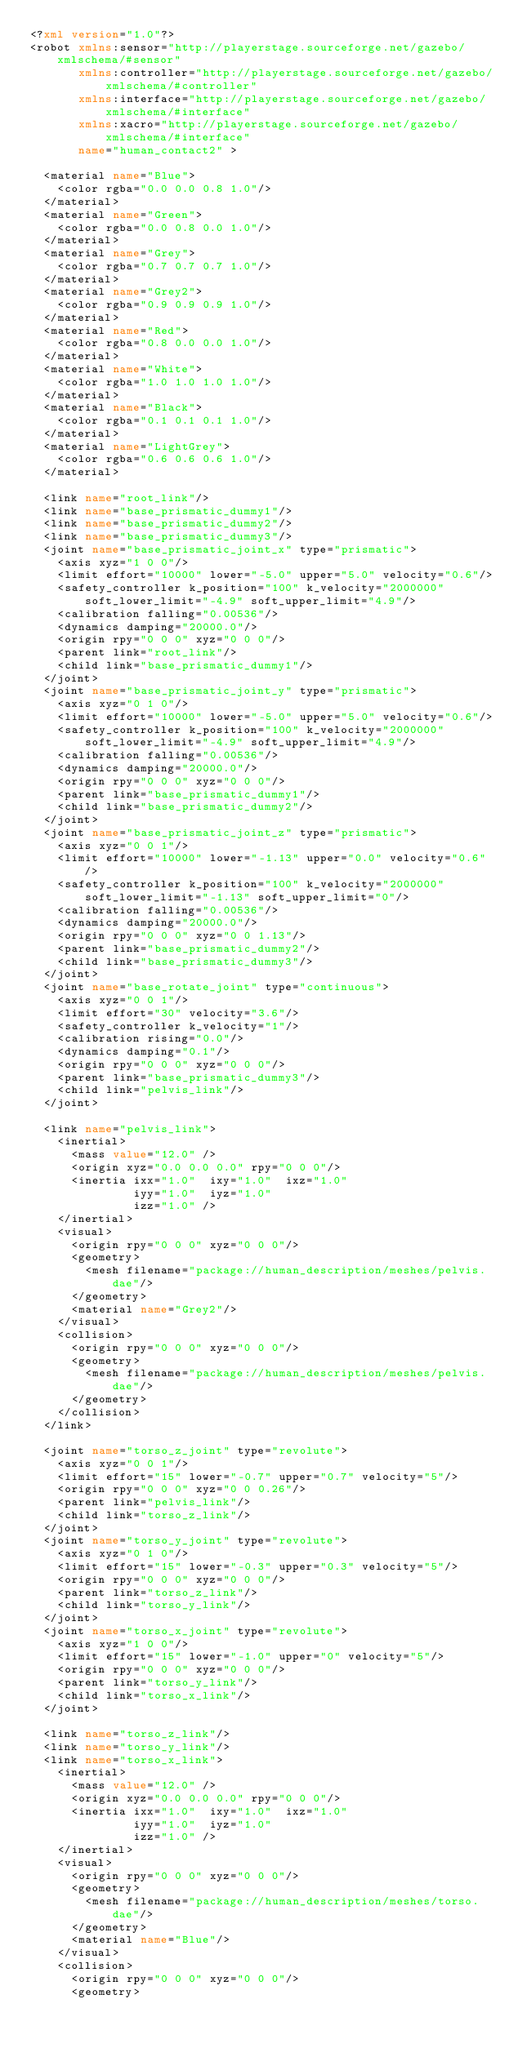<code> <loc_0><loc_0><loc_500><loc_500><_XML_><?xml version="1.0"?>
<robot xmlns:sensor="http://playerstage.sourceforge.net/gazebo/xmlschema/#sensor"
       xmlns:controller="http://playerstage.sourceforge.net/gazebo/xmlschema/#controller"
       xmlns:interface="http://playerstage.sourceforge.net/gazebo/xmlschema/#interface"
       xmlns:xacro="http://playerstage.sourceforge.net/gazebo/xmlschema/#interface"
       name="human_contact2" >

  <material name="Blue">
    <color rgba="0.0 0.0 0.8 1.0"/>
  </material>
  <material name="Green">
    <color rgba="0.0 0.8 0.0 1.0"/>
  </material>
  <material name="Grey">
    <color rgba="0.7 0.7 0.7 1.0"/>
  </material>
  <material name="Grey2">
    <color rgba="0.9 0.9 0.9 1.0"/>
  </material>
  <material name="Red">
    <color rgba="0.8 0.0 0.0 1.0"/>
  </material>
  <material name="White">
    <color rgba="1.0 1.0 1.0 1.0"/>
  </material>
  <material name="Black">
    <color rgba="0.1 0.1 0.1 1.0"/>
  </material>
  <material name="LightGrey">
    <color rgba="0.6 0.6 0.6 1.0"/>
  </material>

  <link name="root_link"/>
  <link name="base_prismatic_dummy1"/>
  <link name="base_prismatic_dummy2"/>
  <link name="base_prismatic_dummy3"/>
  <joint name="base_prismatic_joint_x" type="prismatic">
    <axis xyz="1 0 0"/>
    <limit effort="10000" lower="-5.0" upper="5.0" velocity="0.6"/>
    <safety_controller k_position="100" k_velocity="2000000" soft_lower_limit="-4.9" soft_upper_limit="4.9"/>
    <calibration falling="0.00536"/>
    <dynamics damping="20000.0"/>
    <origin rpy="0 0 0" xyz="0 0 0"/>
    <parent link="root_link"/>
    <child link="base_prismatic_dummy1"/>
  </joint>
  <joint name="base_prismatic_joint_y" type="prismatic">
    <axis xyz="0 1 0"/>
    <limit effort="10000" lower="-5.0" upper="5.0" velocity="0.6"/>
    <safety_controller k_position="100" k_velocity="2000000" soft_lower_limit="-4.9" soft_upper_limit="4.9"/>
    <calibration falling="0.00536"/>
    <dynamics damping="20000.0"/>
    <origin rpy="0 0 0" xyz="0 0 0"/>
    <parent link="base_prismatic_dummy1"/>
    <child link="base_prismatic_dummy2"/>
  </joint>
  <joint name="base_prismatic_joint_z" type="prismatic">
    <axis xyz="0 0 1"/>
    <limit effort="10000" lower="-1.13" upper="0.0" velocity="0.6"/>
    <safety_controller k_position="100" k_velocity="2000000" soft_lower_limit="-1.13" soft_upper_limit="0"/>
    <calibration falling="0.00536"/>
    <dynamics damping="20000.0"/>
    <origin rpy="0 0 0" xyz="0 0 1.13"/>
    <parent link="base_prismatic_dummy2"/>
    <child link="base_prismatic_dummy3"/>
  </joint>
  <joint name="base_rotate_joint" type="continuous">
    <axis xyz="0 0 1"/>
    <limit effort="30" velocity="3.6"/>
    <safety_controller k_velocity="1"/>
    <calibration rising="0.0"/>
    <dynamics damping="0.1"/>
    <origin rpy="0 0 0" xyz="0 0 0"/>
    <parent link="base_prismatic_dummy3"/>
    <child link="pelvis_link"/>
  </joint>

  <link name="pelvis_link">
    <inertial>
      <mass value="12.0" />
      <origin xyz="0.0 0.0 0.0" rpy="0 0 0"/>
      <inertia ixx="1.0"  ixy="1.0"  ixz="1.0"
               iyy="1.0"  iyz="1.0"
               izz="1.0" />
    </inertial>
    <visual>
      <origin rpy="0 0 0" xyz="0 0 0"/>
      <geometry>
        <mesh filename="package://human_description/meshes/pelvis.dae"/>
      </geometry>
      <material name="Grey2"/>
    </visual>
    <collision>
      <origin rpy="0 0 0" xyz="0 0 0"/>
      <geometry>
        <mesh filename="package://human_description/meshes/pelvis.dae"/>
      </geometry>
    </collision>
  </link>

  <joint name="torso_z_joint" type="revolute">
    <axis xyz="0 0 1"/>
    <limit effort="15" lower="-0.7" upper="0.7" velocity="5"/>
    <origin rpy="0 0 0" xyz="0 0 0.26"/>
    <parent link="pelvis_link"/>
    <child link="torso_z_link"/>
  </joint>
  <joint name="torso_y_joint" type="revolute">
    <axis xyz="0 1 0"/>
    <limit effort="15" lower="-0.3" upper="0.3" velocity="5"/>
    <origin rpy="0 0 0" xyz="0 0 0"/>
    <parent link="torso_z_link"/>
    <child link="torso_y_link"/>
  </joint>
  <joint name="torso_x_joint" type="revolute">
    <axis xyz="1 0 0"/>
    <limit effort="15" lower="-1.0" upper="0" velocity="5"/>
    <origin rpy="0 0 0" xyz="0 0 0"/>
    <parent link="torso_y_link"/>
    <child link="torso_x_link"/>
  </joint>

  <link name="torso_z_link"/>
  <link name="torso_y_link"/>
  <link name="torso_x_link">
    <inertial>
      <mass value="12.0" />
      <origin xyz="0.0 0.0 0.0" rpy="0 0 0"/>
      <inertia ixx="1.0"  ixy="1.0"  ixz="1.0"
               iyy="1.0"  iyz="1.0"
               izz="1.0" />
    </inertial>
    <visual>
      <origin rpy="0 0 0" xyz="0 0 0"/>
      <geometry>
        <mesh filename="package://human_description/meshes/torso.dae"/>
      </geometry>
      <material name="Blue"/>
    </visual>
    <collision>
      <origin rpy="0 0 0" xyz="0 0 0"/>
      <geometry></code> 